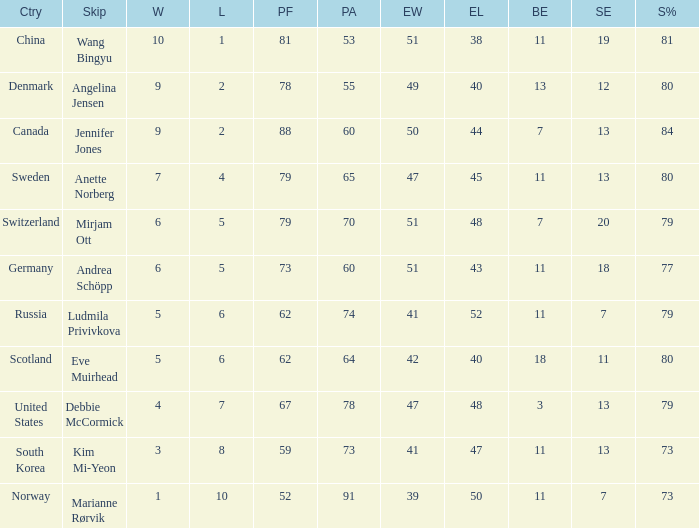What is the minimum Wins a team has? 1.0. 